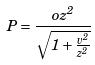Convert formula to latex. <formula><loc_0><loc_0><loc_500><loc_500>P = \frac { o z ^ { 2 } } { \sqrt { 1 + \frac { v ^ { 2 } } { z ^ { 2 } } } }</formula> 